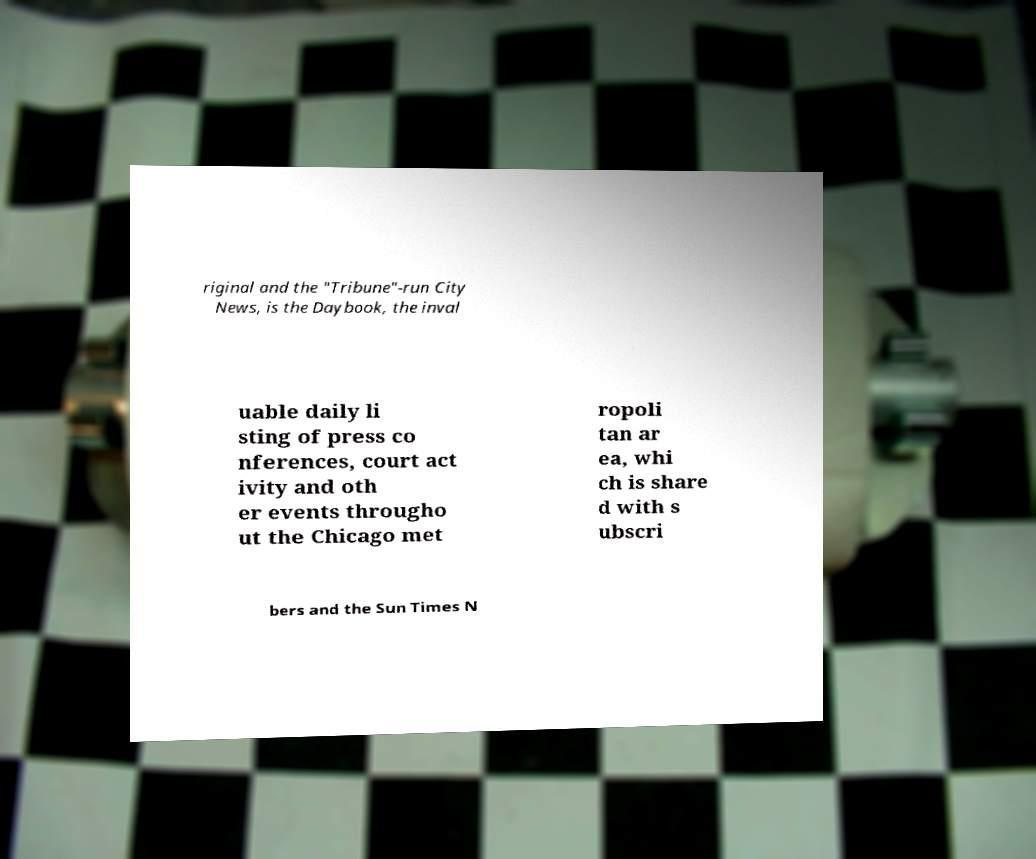Please read and relay the text visible in this image. What does it say? riginal and the "Tribune"-run City News, is the Daybook, the inval uable daily li sting of press co nferences, court act ivity and oth er events througho ut the Chicago met ropoli tan ar ea, whi ch is share d with s ubscri bers and the Sun Times N 